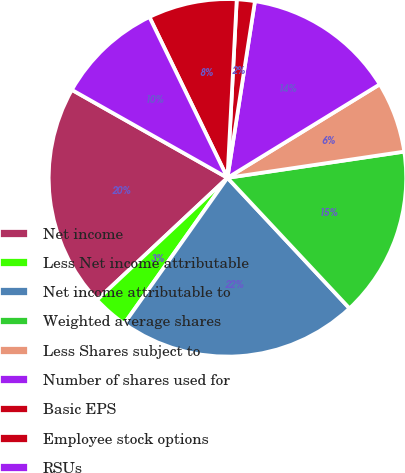<chart> <loc_0><loc_0><loc_500><loc_500><pie_chart><fcel>Net income<fcel>Less Net income attributable<fcel>Net income attributable to<fcel>Weighted average shares<fcel>Less Shares subject to<fcel>Number of shares used for<fcel>Basic EPS<fcel>Employee stock options<fcel>RSUs<nl><fcel>20.17%<fcel>3.22%<fcel>21.77%<fcel>15.38%<fcel>6.42%<fcel>13.78%<fcel>1.63%<fcel>8.02%<fcel>9.62%<nl></chart> 